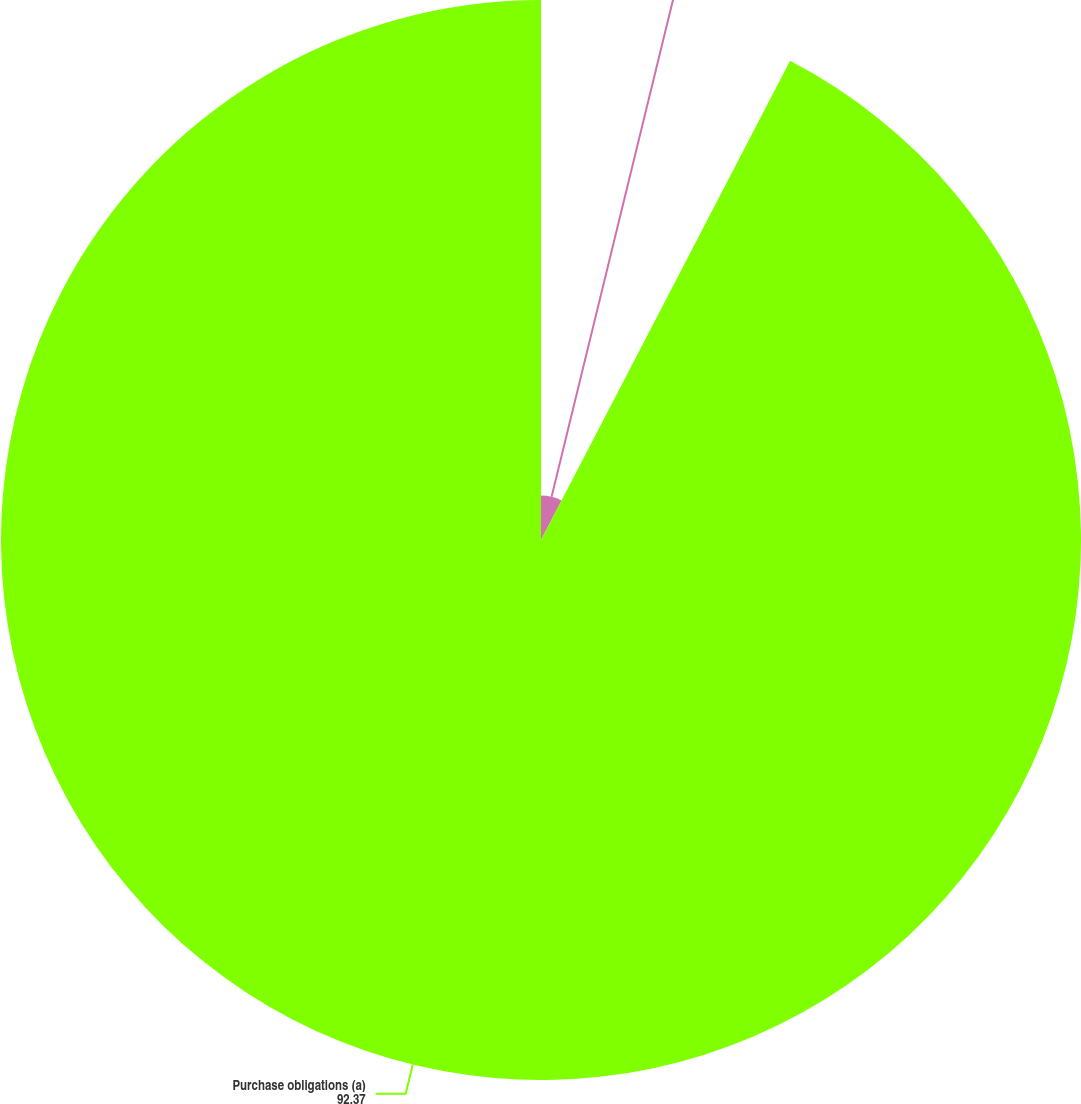Convert chart. <chart><loc_0><loc_0><loc_500><loc_500><pie_chart><fcel>Lease obligations<fcel>Purchase obligations (a)<nl><fcel>7.63%<fcel>92.37%<nl></chart> 